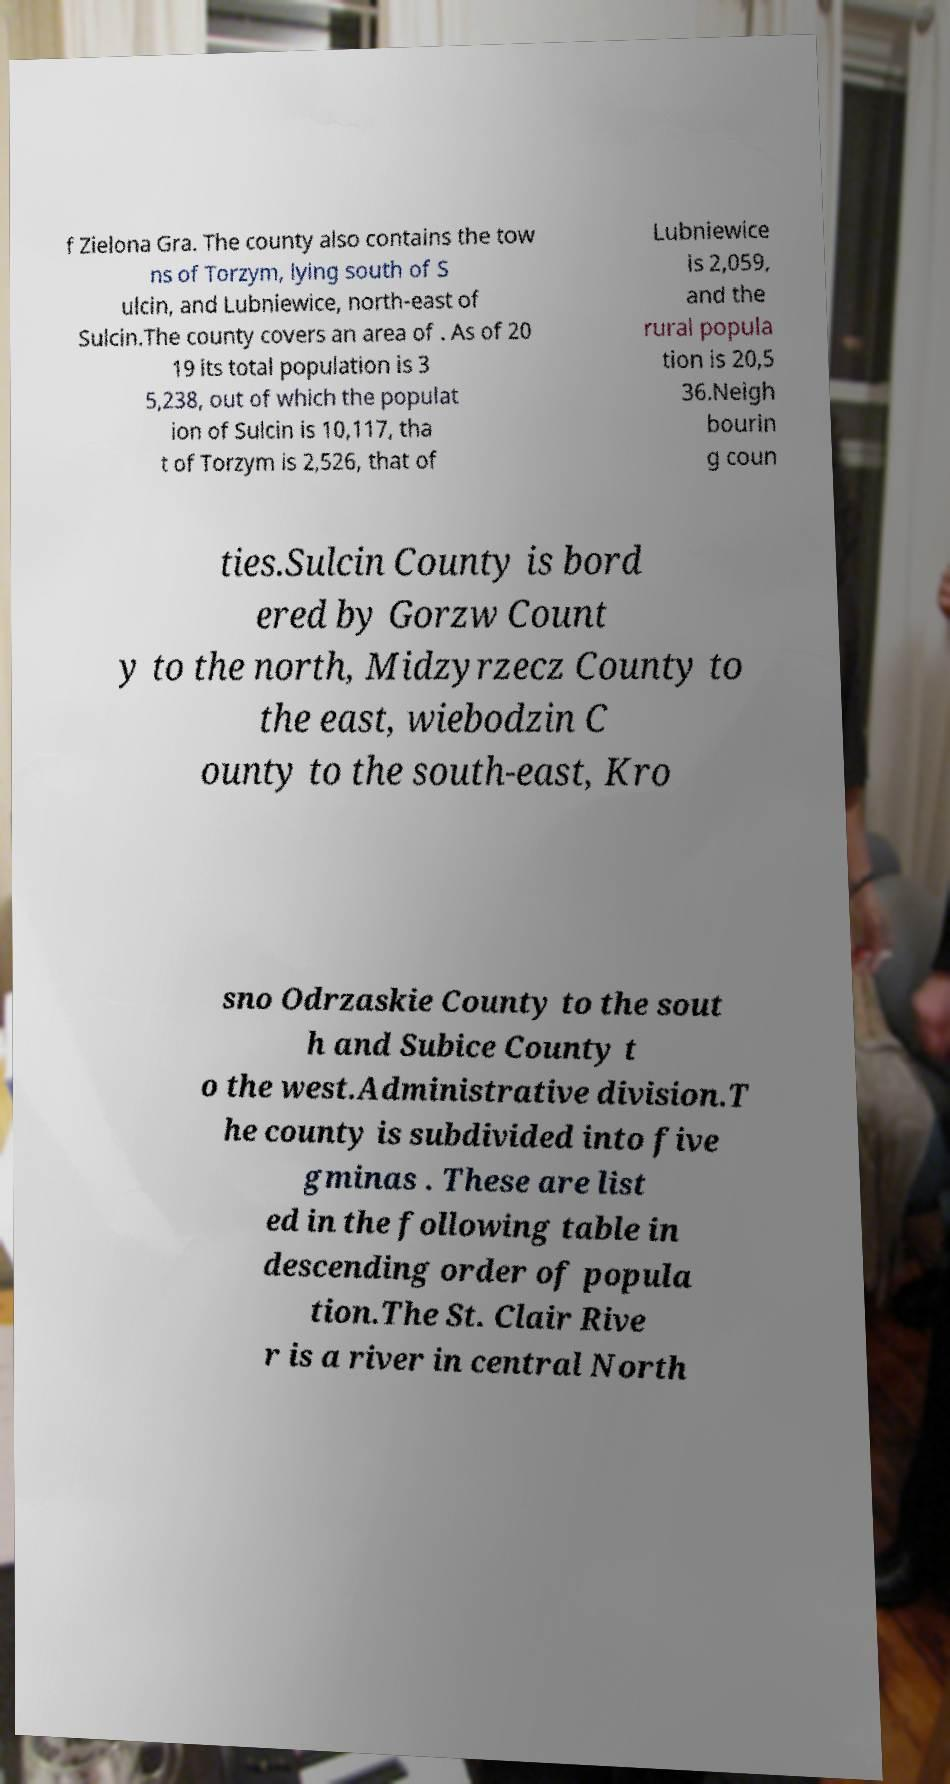Please read and relay the text visible in this image. What does it say? f Zielona Gra. The county also contains the tow ns of Torzym, lying south of S ulcin, and Lubniewice, north-east of Sulcin.The county covers an area of . As of 20 19 its total population is 3 5,238, out of which the populat ion of Sulcin is 10,117, tha t of Torzym is 2,526, that of Lubniewice is 2,059, and the rural popula tion is 20,5 36.Neigh bourin g coun ties.Sulcin County is bord ered by Gorzw Count y to the north, Midzyrzecz County to the east, wiebodzin C ounty to the south-east, Kro sno Odrzaskie County to the sout h and Subice County t o the west.Administrative division.T he county is subdivided into five gminas . These are list ed in the following table in descending order of popula tion.The St. Clair Rive r is a river in central North 